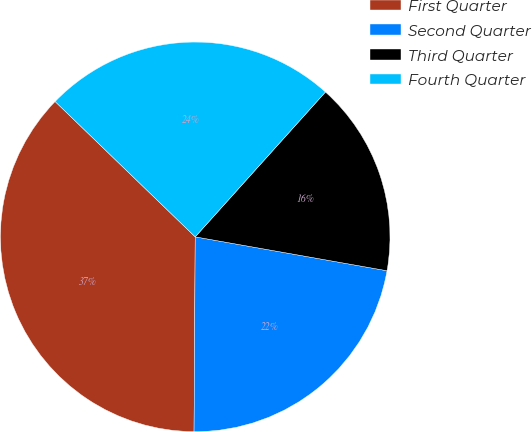Convert chart to OTSL. <chart><loc_0><loc_0><loc_500><loc_500><pie_chart><fcel>First Quarter<fcel>Second Quarter<fcel>Third Quarter<fcel>Fourth Quarter<nl><fcel>37.13%<fcel>22.31%<fcel>16.13%<fcel>24.43%<nl></chart> 